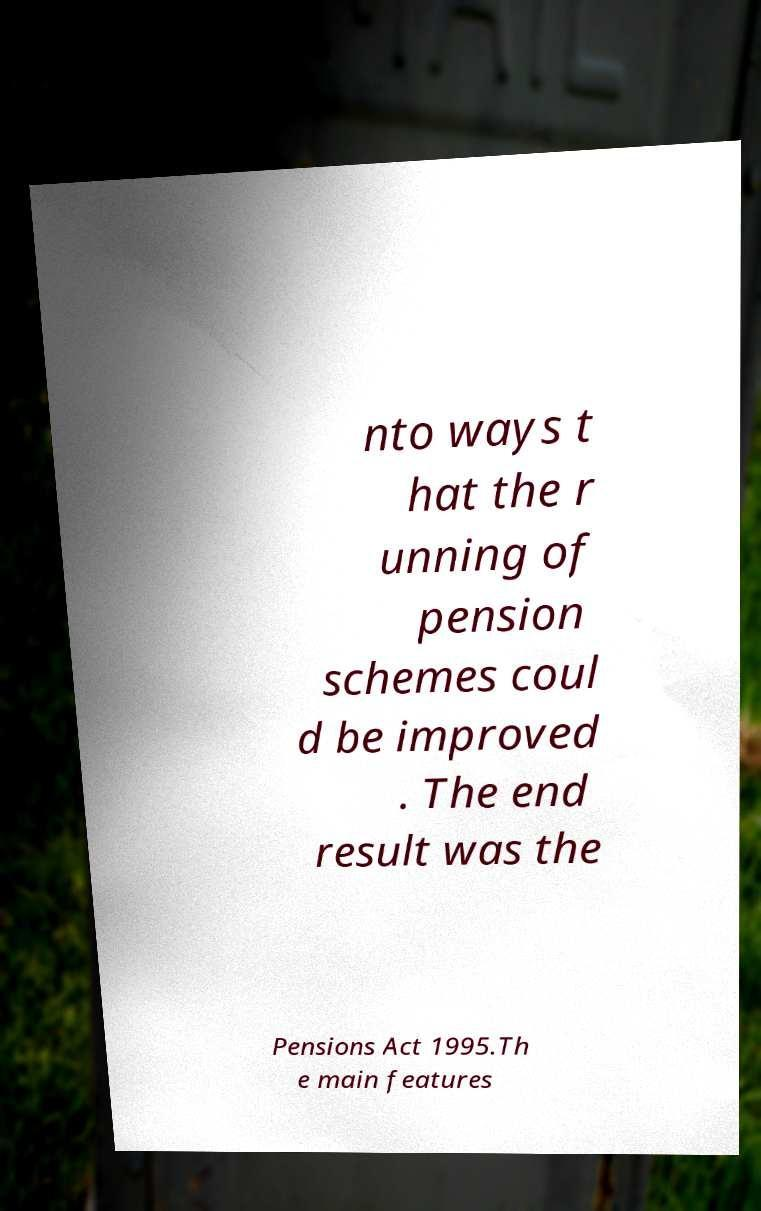For documentation purposes, I need the text within this image transcribed. Could you provide that? nto ways t hat the r unning of pension schemes coul d be improved . The end result was the Pensions Act 1995.Th e main features 